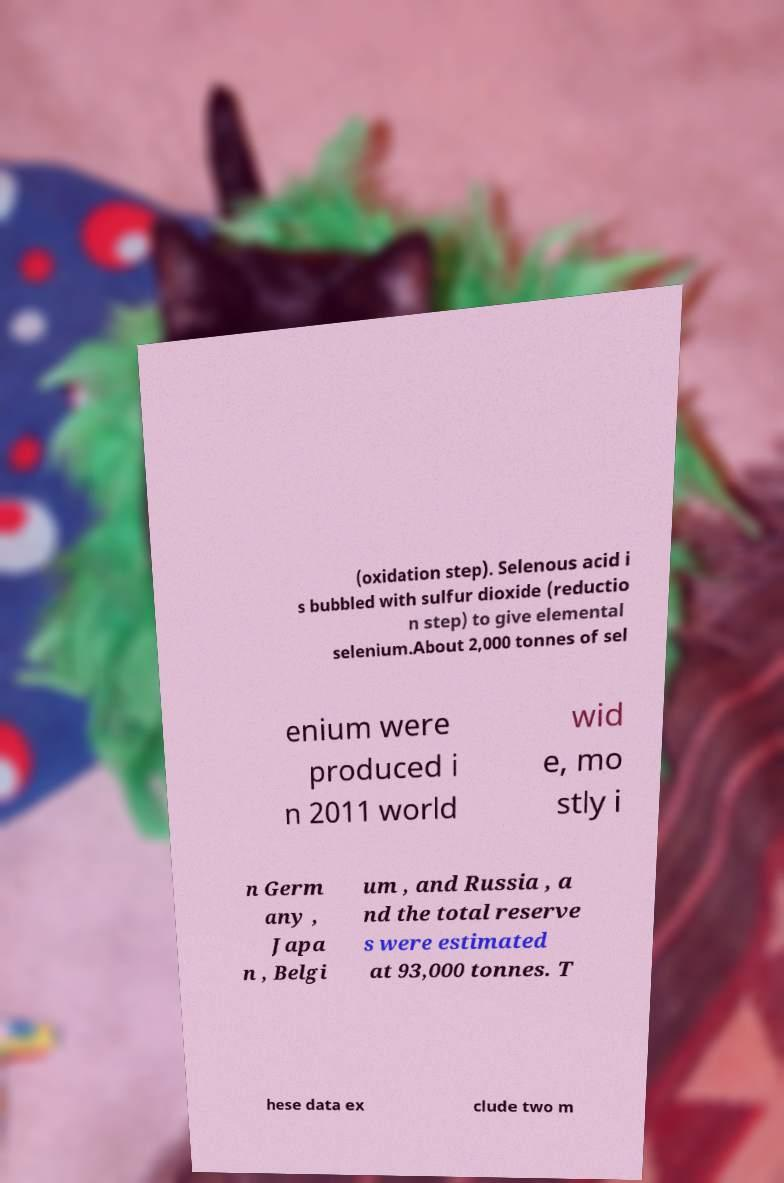Can you read and provide the text displayed in the image?This photo seems to have some interesting text. Can you extract and type it out for me? (oxidation step). Selenous acid i s bubbled with sulfur dioxide (reductio n step) to give elemental selenium.About 2,000 tonnes of sel enium were produced i n 2011 world wid e, mo stly i n Germ any , Japa n , Belgi um , and Russia , a nd the total reserve s were estimated at 93,000 tonnes. T hese data ex clude two m 